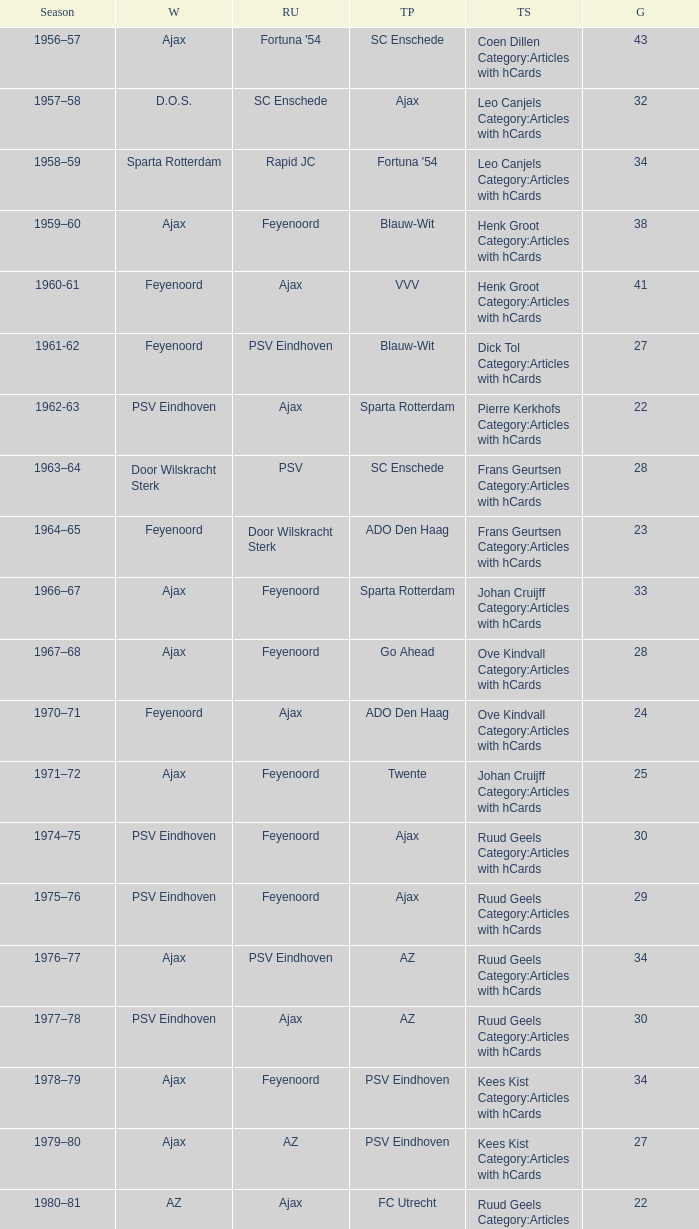When twente came in third place and ajax was the winner what are the seasons? 1971–72, 1989-90. 